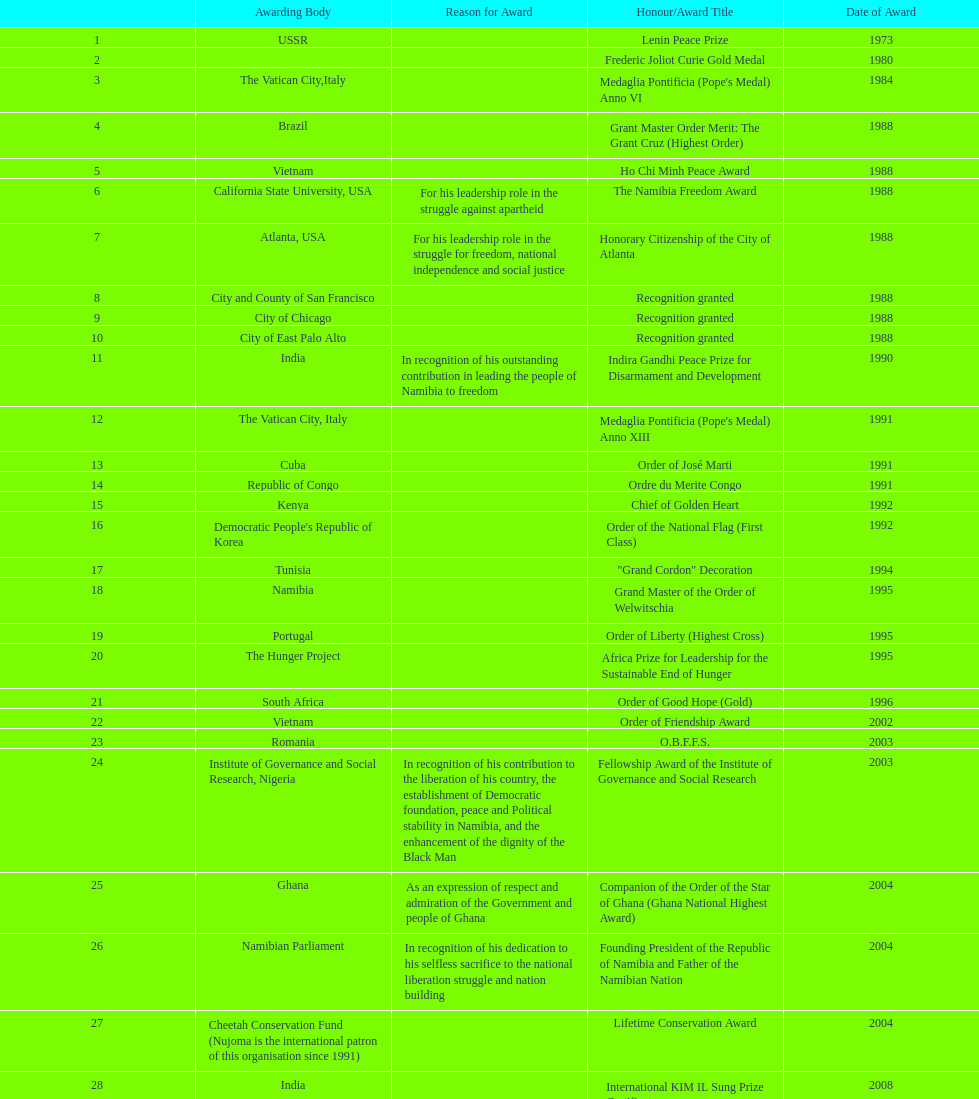What is the difference between the number of awards won in 1988 and the number of awards won in 1995? 4. 